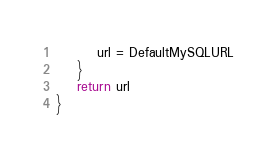Convert code to text. <code><loc_0><loc_0><loc_500><loc_500><_Go_>		url = DefaultMySQLURL
	}
	return url
}
</code> 